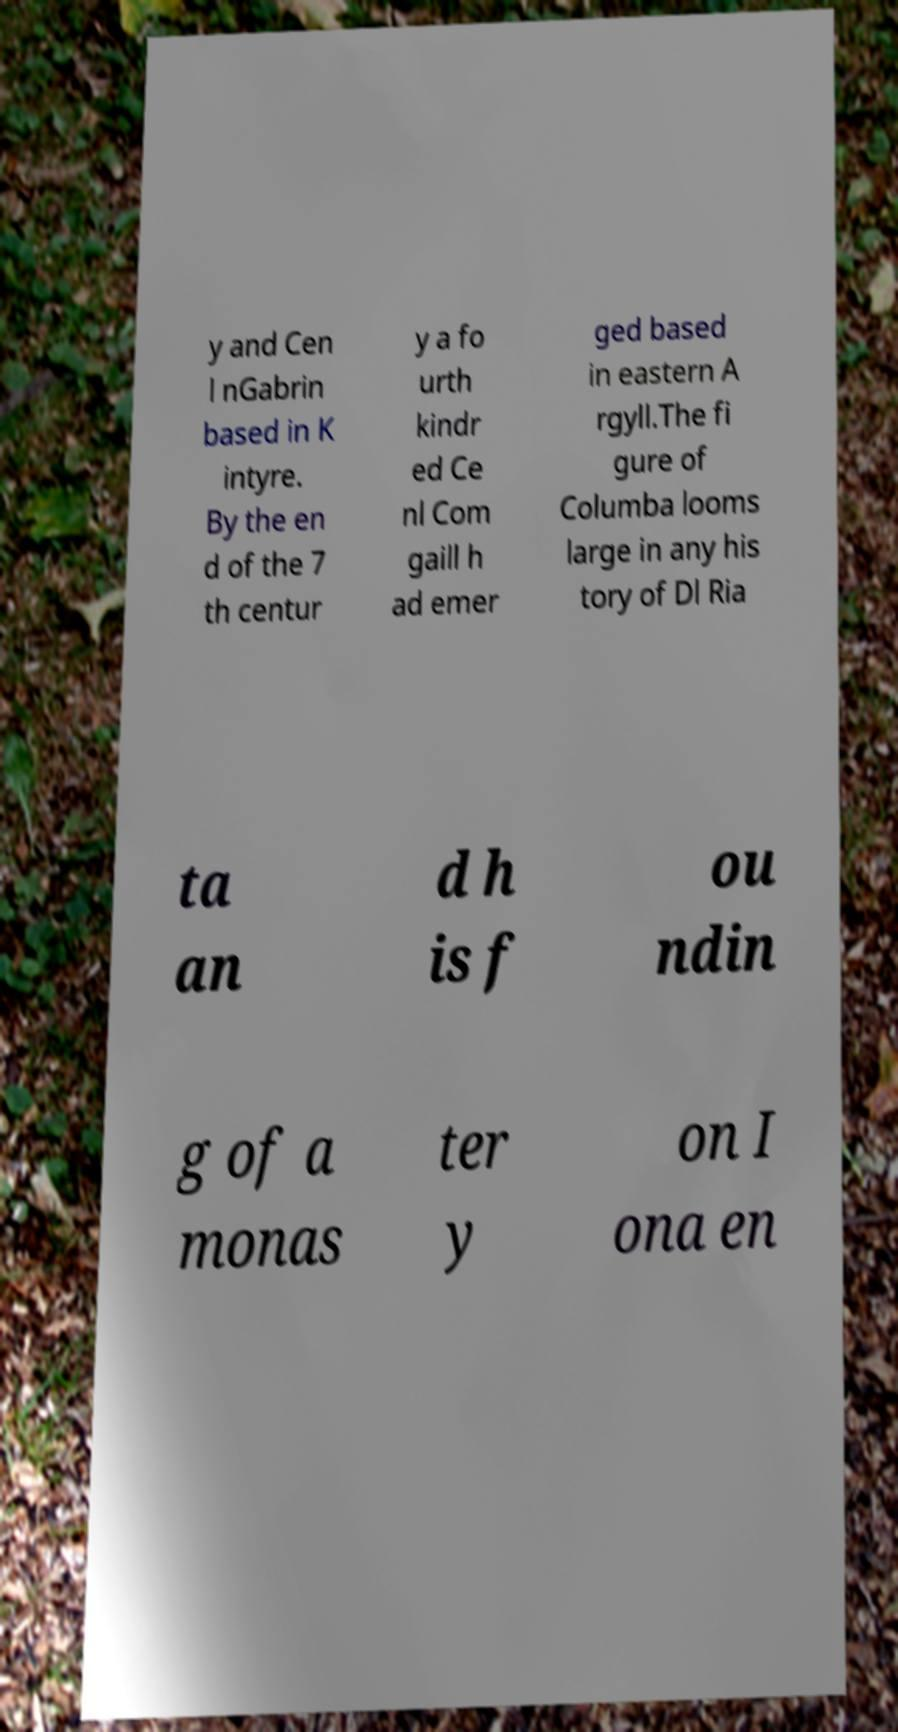There's text embedded in this image that I need extracted. Can you transcribe it verbatim? y and Cen l nGabrin based in K intyre. By the en d of the 7 th centur y a fo urth kindr ed Ce nl Com gaill h ad emer ged based in eastern A rgyll.The fi gure of Columba looms large in any his tory of Dl Ria ta an d h is f ou ndin g of a monas ter y on I ona en 